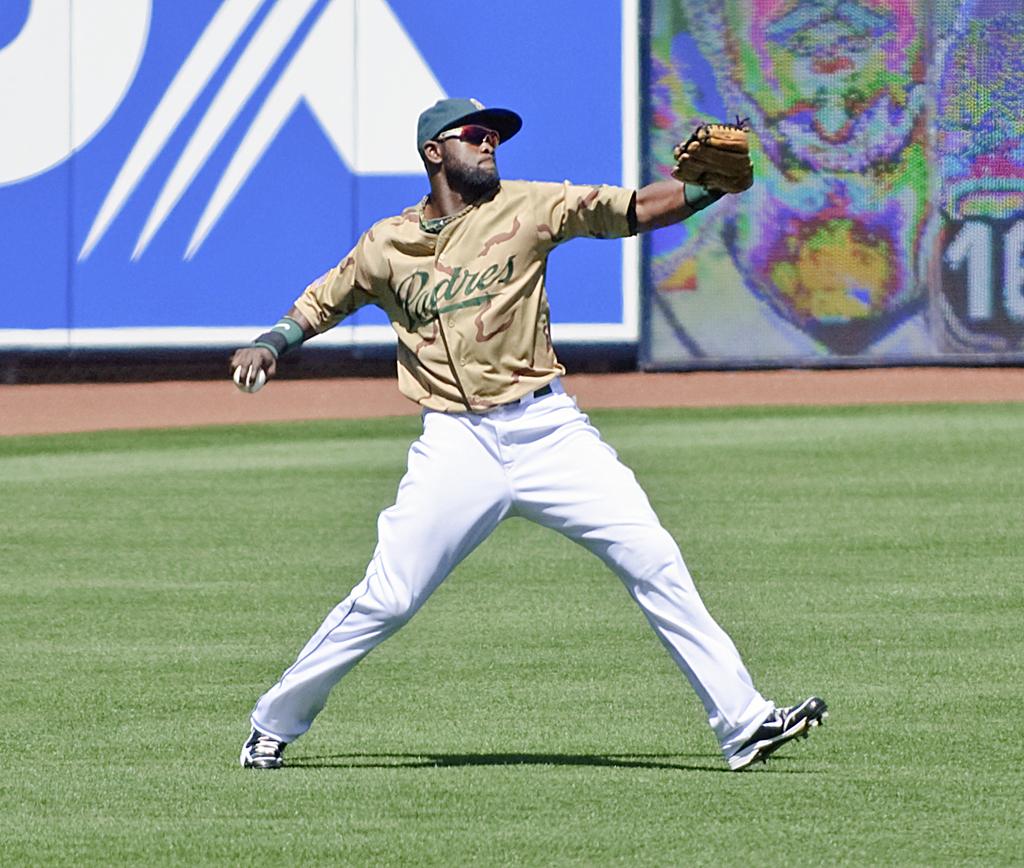What team does this player play for?
Your response must be concise. Padres. 